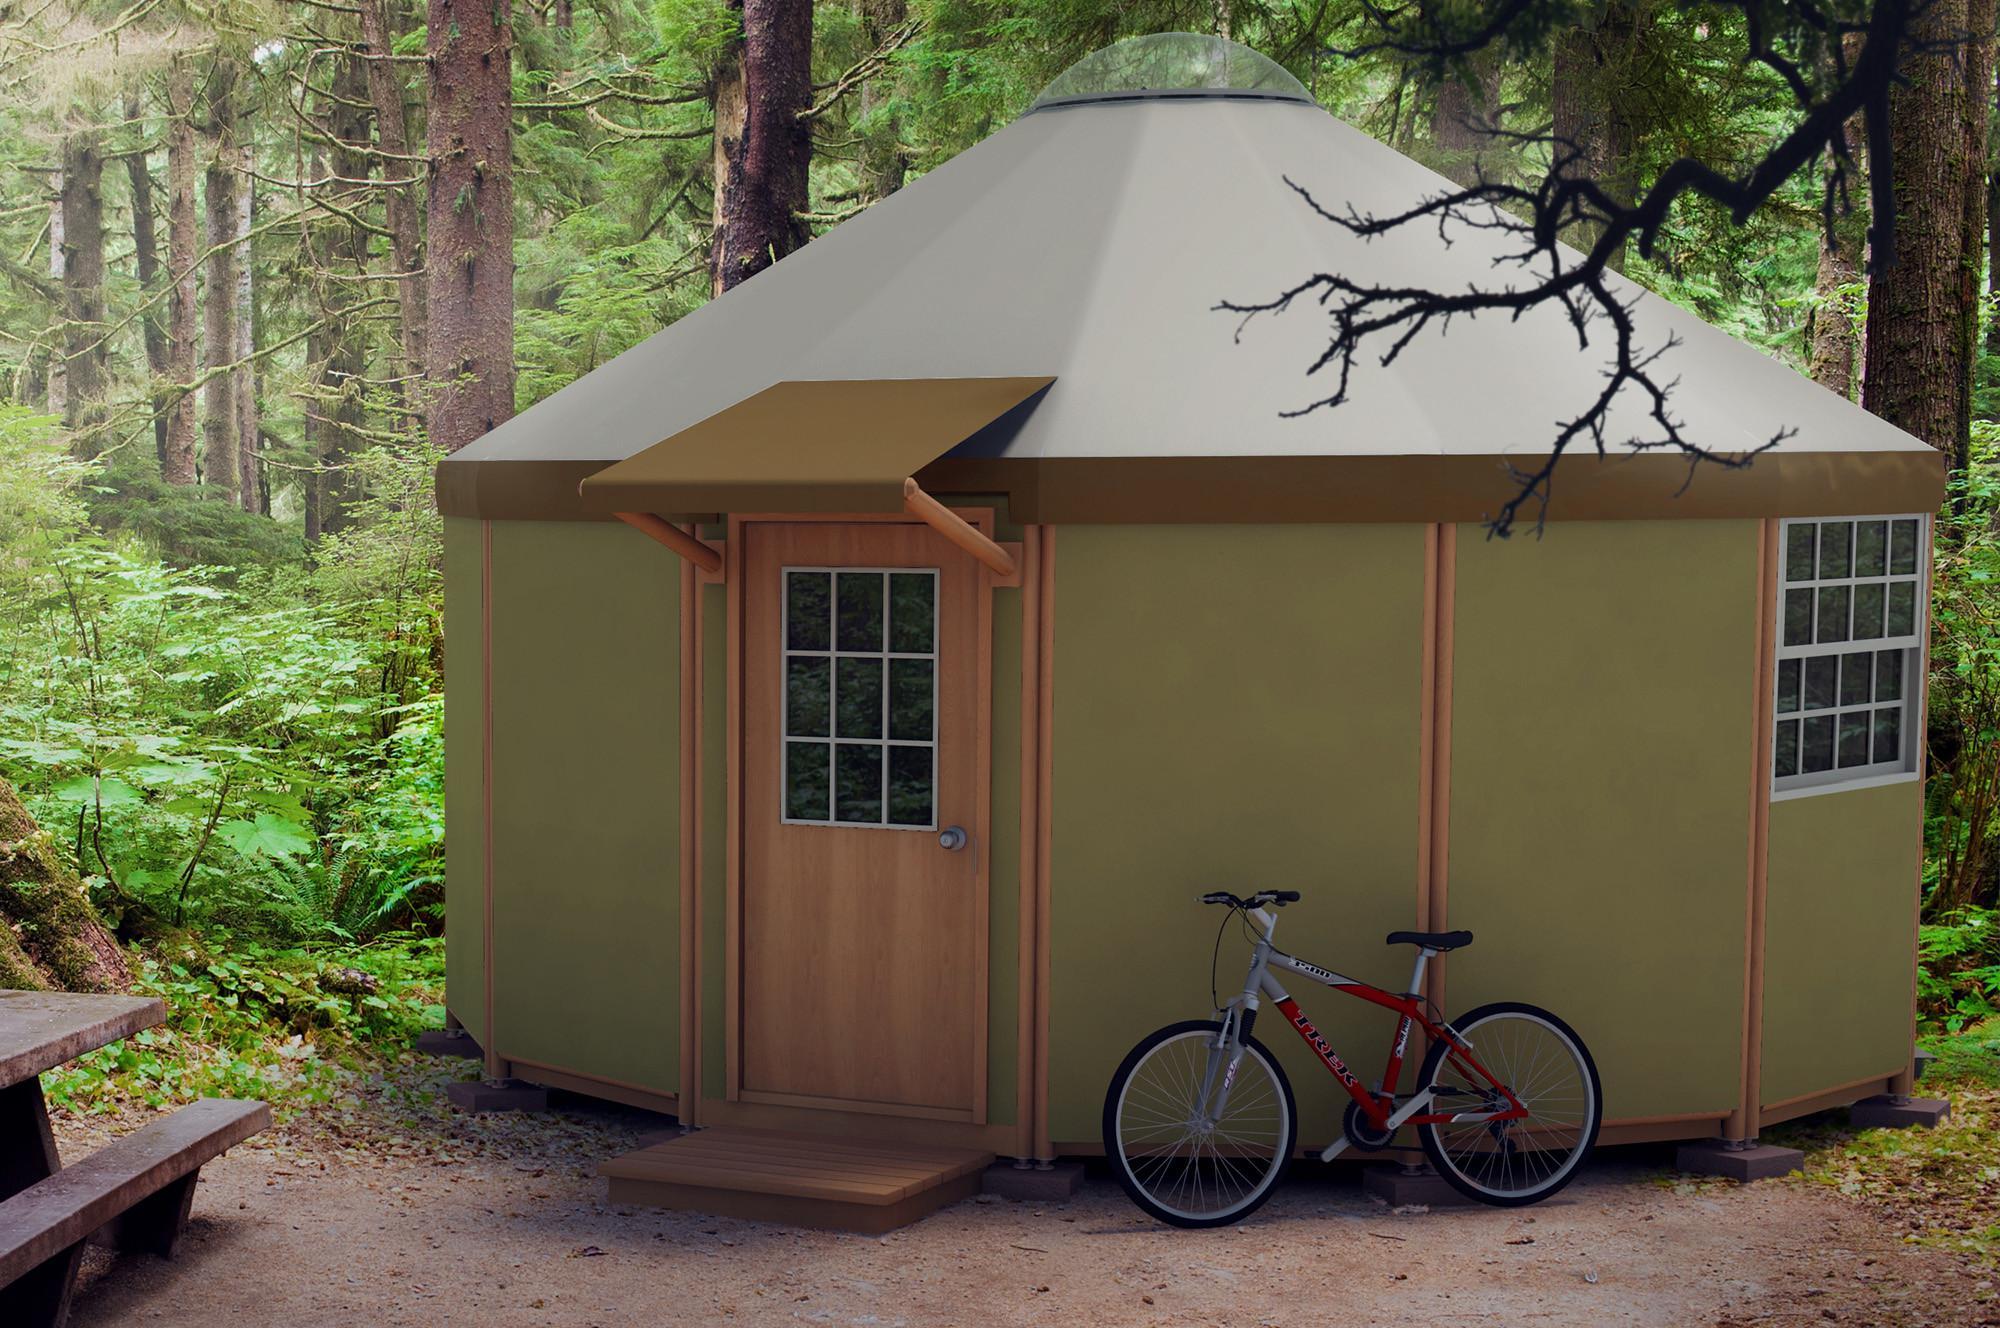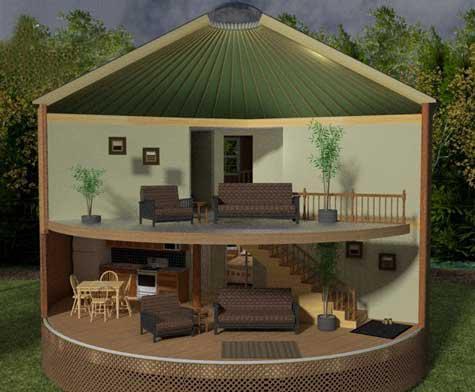The first image is the image on the left, the second image is the image on the right. Considering the images on both sides, is "An image shows a round house with a railing above two white garage doors." valid? Answer yes or no. No. The first image is the image on the left, the second image is the image on the right. For the images displayed, is the sentence "Each of two yurts has two distinct levels and one or more fenced wooden deck sections." factually correct? Answer yes or no. No. 